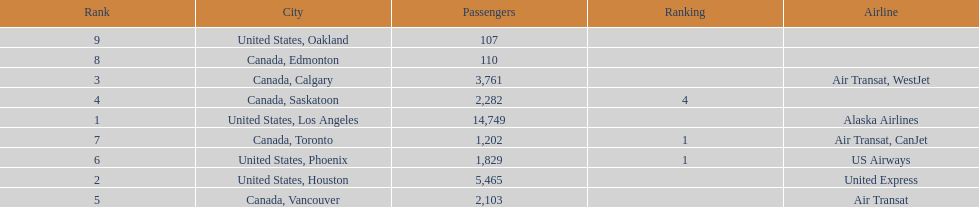Could you parse the entire table? {'header': ['Rank', 'City', 'Passengers', 'Ranking', 'Airline'], 'rows': [['9', 'United States, Oakland', '107', '', ''], ['8', 'Canada, Edmonton', '110', '', ''], ['3', 'Canada, Calgary', '3,761', '', 'Air Transat, WestJet'], ['4', 'Canada, Saskatoon', '2,282', '4', ''], ['1', 'United States, Los Angeles', '14,749', '', 'Alaska Airlines'], ['7', 'Canada, Toronto', '1,202', '1', 'Air Transat, CanJet'], ['6', 'United States, Phoenix', '1,829', '1', 'US Airways'], ['2', 'United States, Houston', '5,465', '', 'United Express'], ['5', 'Canada, Vancouver', '2,103', '', 'Air Transat']]} The difference in passengers between los angeles and toronto 13,547. 